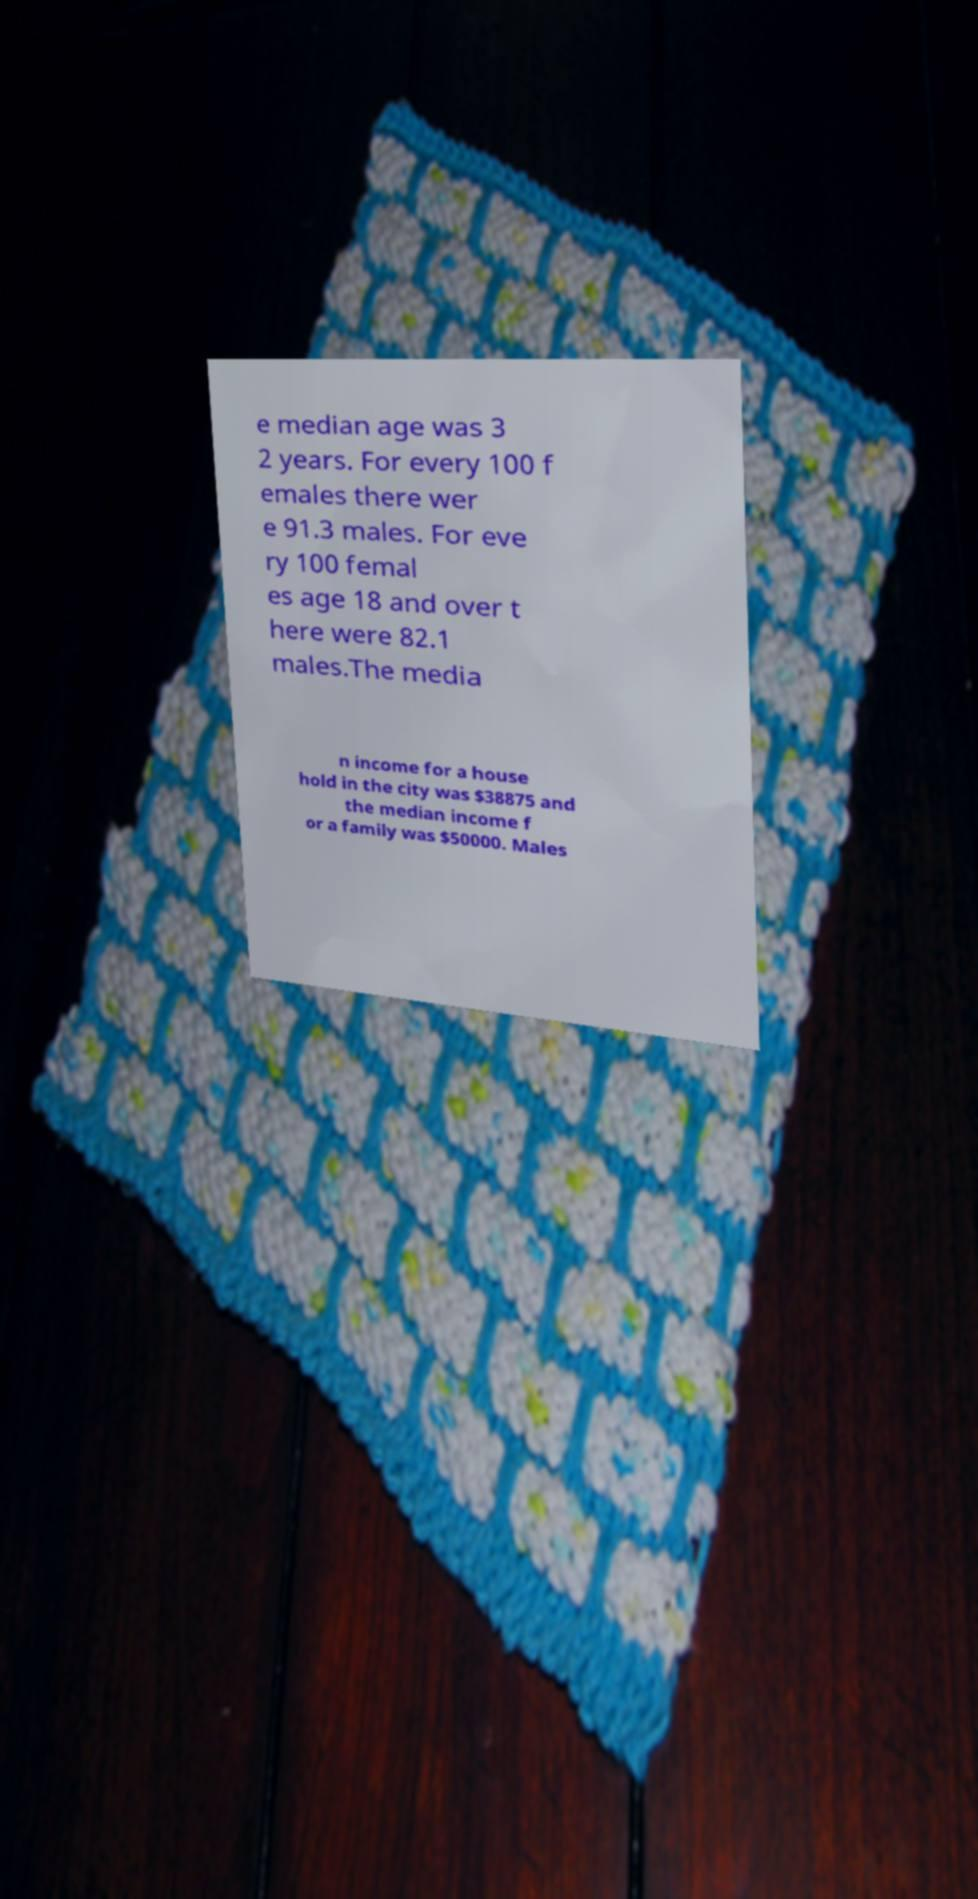Please identify and transcribe the text found in this image. e median age was 3 2 years. For every 100 f emales there wer e 91.3 males. For eve ry 100 femal es age 18 and over t here were 82.1 males.The media n income for a house hold in the city was $38875 and the median income f or a family was $50000. Males 